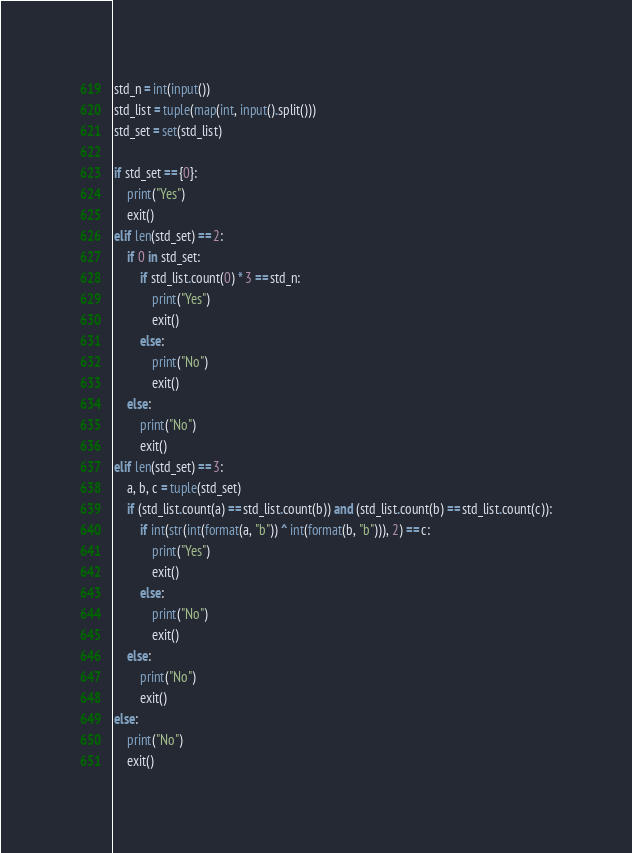<code> <loc_0><loc_0><loc_500><loc_500><_Python_>std_n = int(input())
std_list = tuple(map(int, input().split()))
std_set = set(std_list)

if std_set == {0}:
    print("Yes")
    exit()
elif len(std_set) == 2:
    if 0 in std_set:
        if std_list.count(0) * 3 == std_n:
            print("Yes")
            exit()
        else:
            print("No")
            exit()
    else:
        print("No")
        exit()
elif len(std_set) == 3:
    a, b, c = tuple(std_set)
    if (std_list.count(a) == std_list.count(b)) and (std_list.count(b) == std_list.count(c)):
        if int(str(int(format(a, "b")) ^ int(format(b, "b"))), 2) == c:
            print("Yes")
            exit()
        else:
            print("No")
            exit()
    else:
        print("No")
        exit()
else:
    print("No")
    exit()</code> 